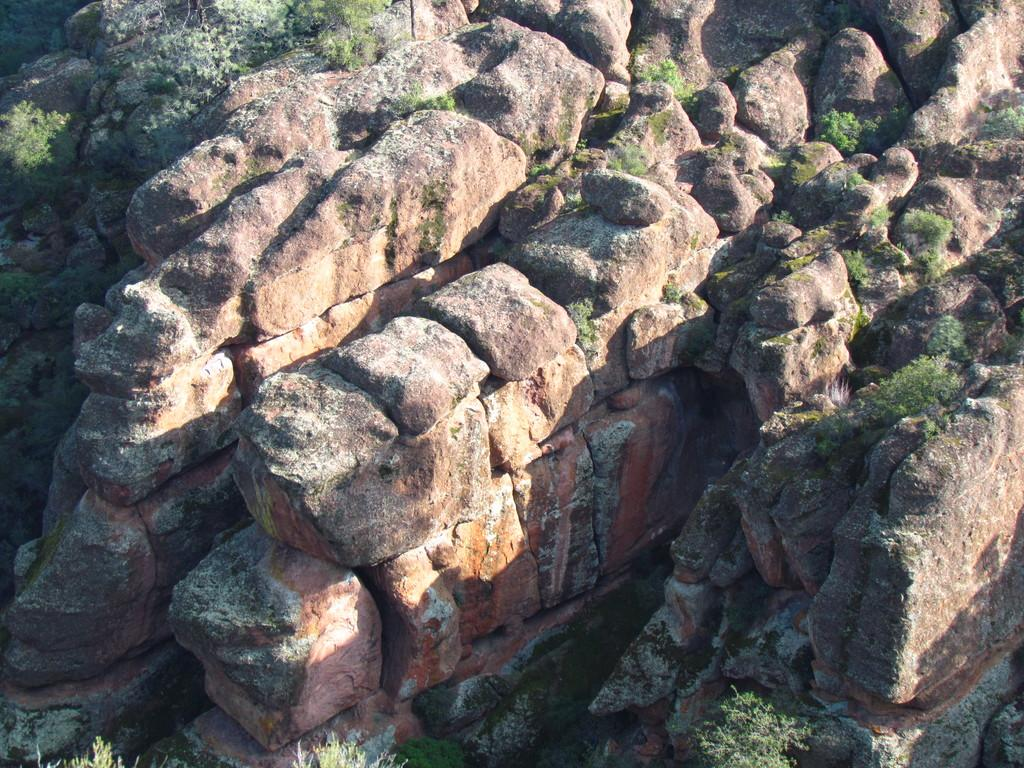What type of natural elements can be seen in the image? There are stones and plants in the image. Can you describe the stones in the image? The stones in the image are likely rocks or pebbles. What kind of plants are present in the image? The plants in the image could be various types of vegetation, such as grass, flowers, or shrubs. What force is causing the waves to crash against the harbor in the image? There is no harbor or waves present in the image; it features stones and plants. 